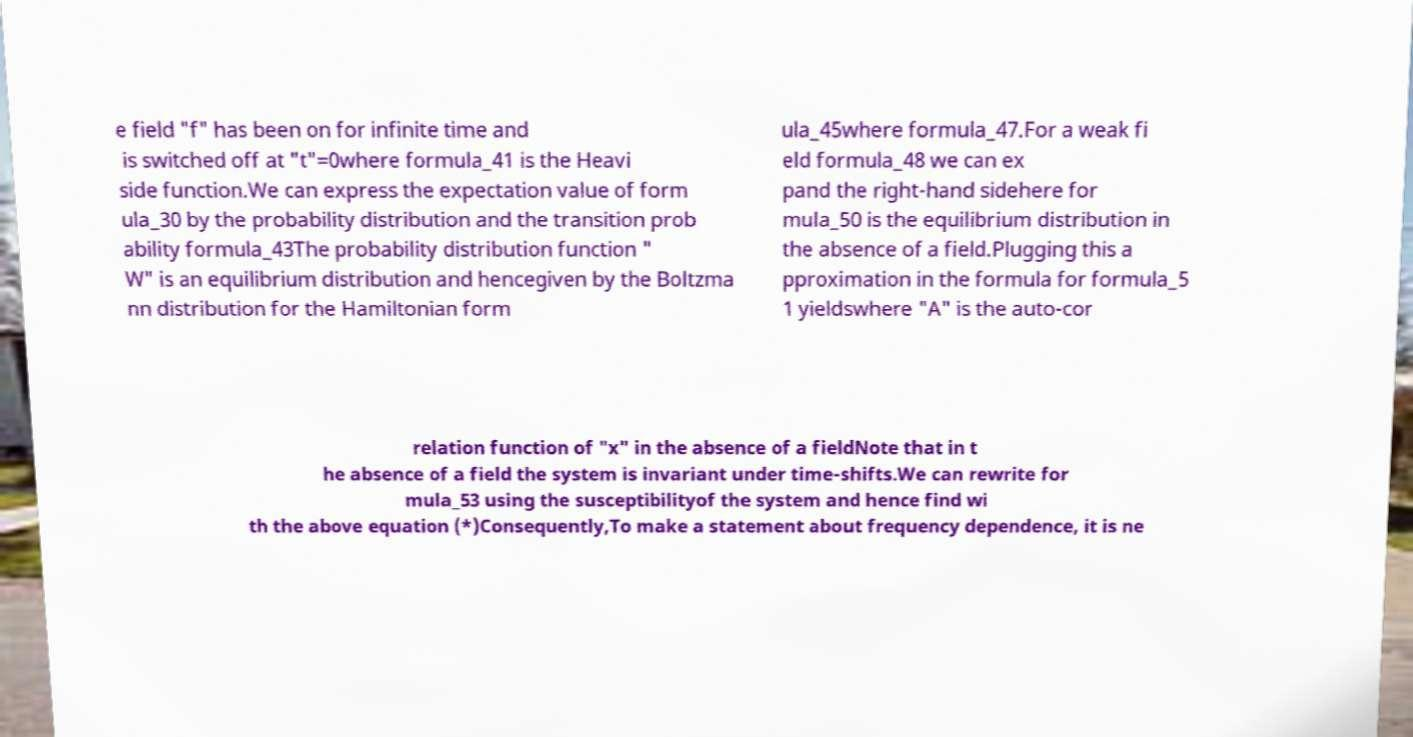Please read and relay the text visible in this image. What does it say? e field "f" has been on for infinite time and is switched off at "t"=0where formula_41 is the Heavi side function.We can express the expectation value of form ula_30 by the probability distribution and the transition prob ability formula_43The probability distribution function " W" is an equilibrium distribution and hencegiven by the Boltzma nn distribution for the Hamiltonian form ula_45where formula_47.For a weak fi eld formula_48 we can ex pand the right-hand sidehere for mula_50 is the equilibrium distribution in the absence of a field.Plugging this a pproximation in the formula for formula_5 1 yieldswhere "A" is the auto-cor relation function of "x" in the absence of a fieldNote that in t he absence of a field the system is invariant under time-shifts.We can rewrite for mula_53 using the susceptibilityof the system and hence find wi th the above equation (*)Consequently,To make a statement about frequency dependence, it is ne 